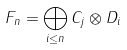<formula> <loc_0><loc_0><loc_500><loc_500>F _ { n } = \bigoplus _ { i \leq n } C _ { j } \otimes D _ { i }</formula> 